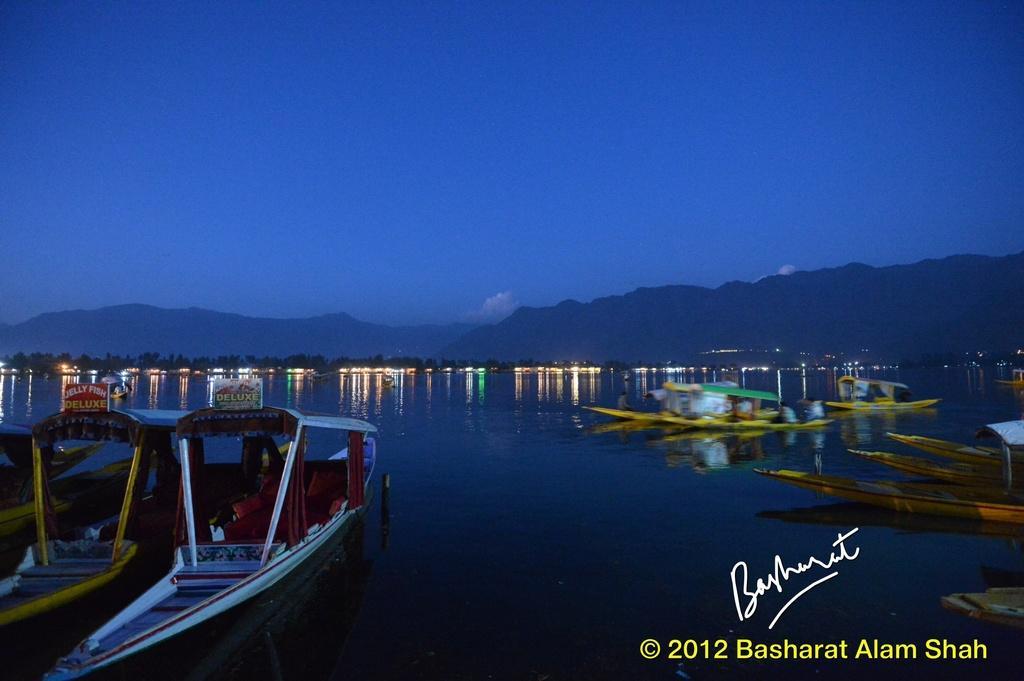In one or two sentences, can you explain what this image depicts? In this image we can see a few boats on the water, far we can see some trees, lights and mountains, in the background, we can see the sky with clouds, at the bottom of the image we can see some text. 